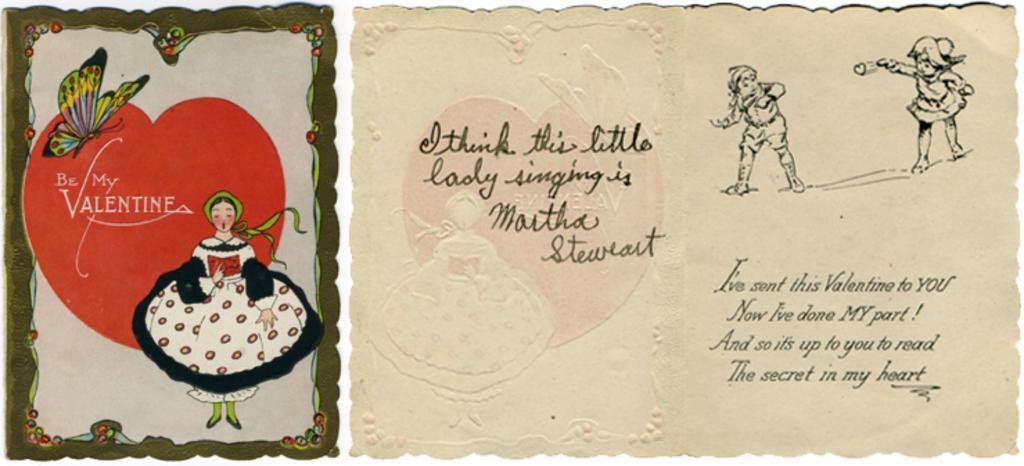Could you give a brief overview of what you see in this image? In this picture we can see a greeting card. We can a butterfly and a lady singing on this card. There is a girl throwing heart to a person. 